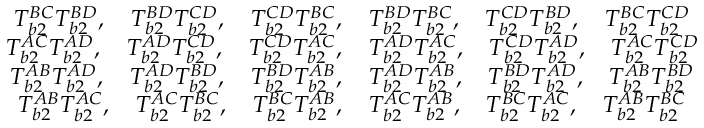Convert formula to latex. <formula><loc_0><loc_0><loc_500><loc_500>\begin{array} { c c } { T _ { b 2 } ^ { B C } T _ { b 2 } ^ { B D } , \quad T _ { b 2 } ^ { B D } T _ { b 2 } ^ { C D } , \quad T _ { b 2 } ^ { C D } T _ { b 2 } ^ { B C } , \quad T _ { b 2 } ^ { B D } T _ { b 2 } ^ { B C } , \quad T _ { b 2 } ^ { C D } T _ { b 2 } ^ { B D } , \quad T _ { b 2 } ^ { B C } T _ { b 2 } ^ { C D } } \\ { T _ { b 2 } ^ { A C } T _ { b 2 } ^ { A D } , \quad T _ { b 2 } ^ { A D } T _ { b 2 } ^ { C D } , \quad T _ { b 2 } ^ { C D } T _ { b 2 } ^ { A C } , \quad T _ { b 2 } ^ { A D } T _ { b 2 } ^ { A C } , \quad T _ { b 2 } ^ { C D } T _ { b 2 } ^ { A D } , \quad T _ { b 2 } ^ { A C } T _ { b 2 } ^ { C D } } \\ { T _ { b 2 } ^ { A B } T _ { b 2 } ^ { A D } , \quad T _ { b 2 } ^ { A D } T _ { b 2 } ^ { B D } , \quad T _ { b 2 } ^ { B D } T _ { b 2 } ^ { A B } , \quad T _ { b 2 } ^ { A D } T _ { b 2 } ^ { A B } , \quad T _ { b 2 } ^ { B D } T _ { b 2 } ^ { A D } , \quad T _ { b 2 } ^ { A B } T _ { b 2 } ^ { B D } } \\ { T _ { b 2 } ^ { A B } T _ { b 2 } ^ { A C } , \quad T _ { b 2 } ^ { A C } T _ { b 2 } ^ { B C } , \quad T _ { b 2 } ^ { B C } T _ { b 2 } ^ { A B } , \quad T _ { b 2 } ^ { A C } T _ { b 2 } ^ { A B } , \quad T _ { b 2 } ^ { B C } T _ { b 2 } ^ { A C } , \quad T _ { b 2 } ^ { A B } T _ { b 2 } ^ { B C } } \end{array}</formula> 